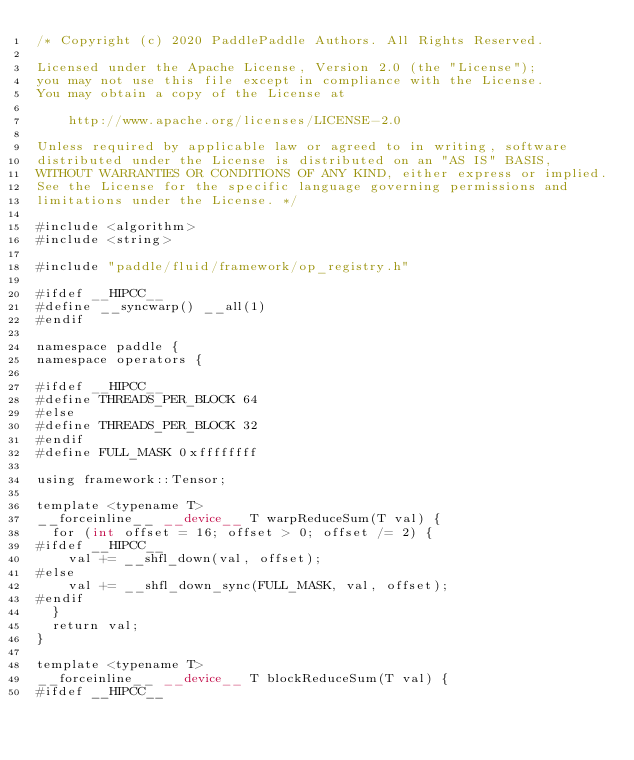<code> <loc_0><loc_0><loc_500><loc_500><_Cuda_>/* Copyright (c) 2020 PaddlePaddle Authors. All Rights Reserved.

Licensed under the Apache License, Version 2.0 (the "License");
you may not use this file except in compliance with the License.
You may obtain a copy of the License at

    http://www.apache.org/licenses/LICENSE-2.0

Unless required by applicable law or agreed to in writing, software
distributed under the License is distributed on an "AS IS" BASIS,
WITHOUT WARRANTIES OR CONDITIONS OF ANY KIND, either express or implied.
See the License for the specific language governing permissions and
limitations under the License. */

#include <algorithm>
#include <string>

#include "paddle/fluid/framework/op_registry.h"

#ifdef __HIPCC__
#define __syncwarp() __all(1)
#endif

namespace paddle {
namespace operators {

#ifdef __HIPCC__
#define THREADS_PER_BLOCK 64
#else
#define THREADS_PER_BLOCK 32
#endif
#define FULL_MASK 0xffffffff

using framework::Tensor;

template <typename T>
__forceinline__ __device__ T warpReduceSum(T val) {
  for (int offset = 16; offset > 0; offset /= 2) {
#ifdef __HIPCC__
    val += __shfl_down(val, offset);
#else
    val += __shfl_down_sync(FULL_MASK, val, offset);
#endif
  }
  return val;
}

template <typename T>
__forceinline__ __device__ T blockReduceSum(T val) {
#ifdef __HIPCC__</code> 